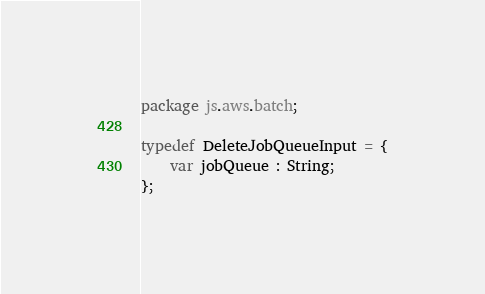<code> <loc_0><loc_0><loc_500><loc_500><_Haxe_>package js.aws.batch;

typedef DeleteJobQueueInput = {
    var jobQueue : String;
};
</code> 